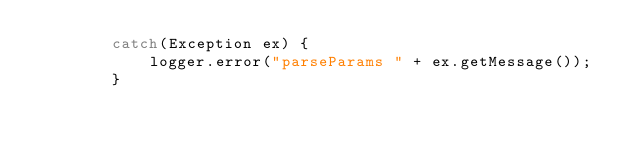Convert code to text. <code><loc_0><loc_0><loc_500><loc_500><_Java_>        catch(Exception ex) {
            logger.error("parseParams " + ex.getMessage());
        }
</code> 